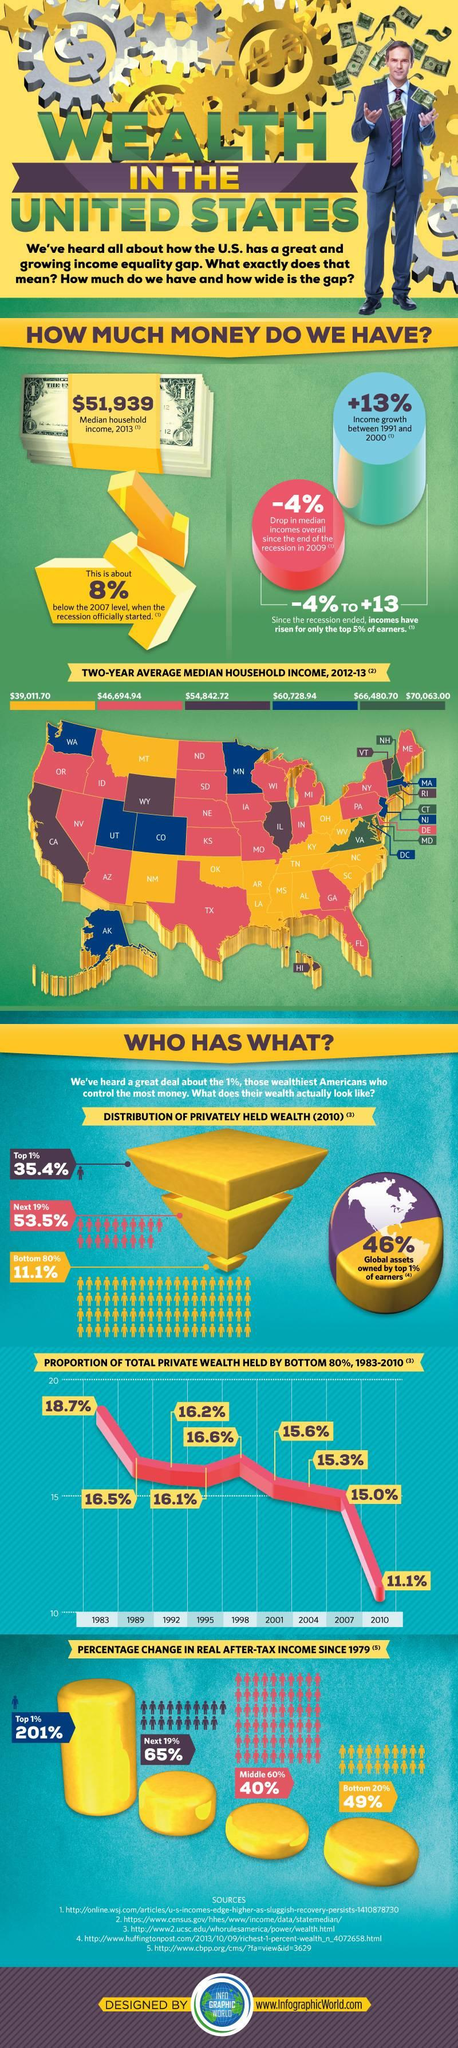Indicate a few pertinent items in this graphic. According to data from 2013, the median household income was $51,939. The top 1% of earners own approximately 46% of global assets. Four states have a median household income above $66,480.70. The two-year average median household income for the state of California is $54,842.72. The two-year average median household income in Texas is $46,694.94. 